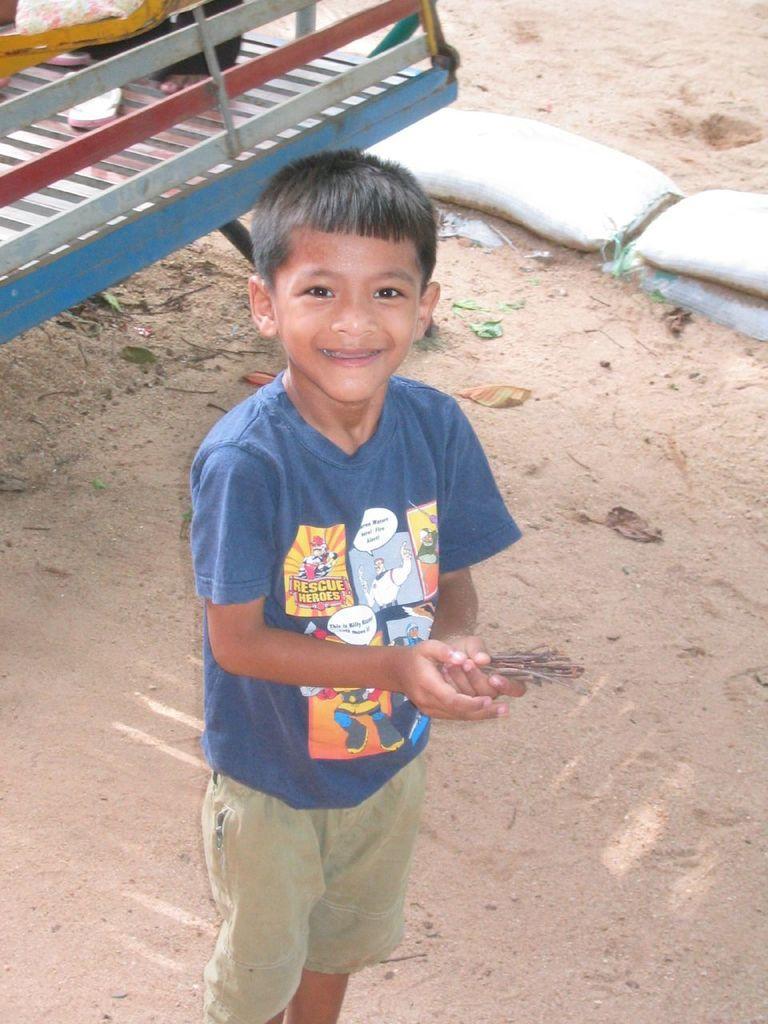How would you summarize this image in a sentence or two? In this image, there is a boy standing and wearing clothes. There are sandbags in the top right of the image. 